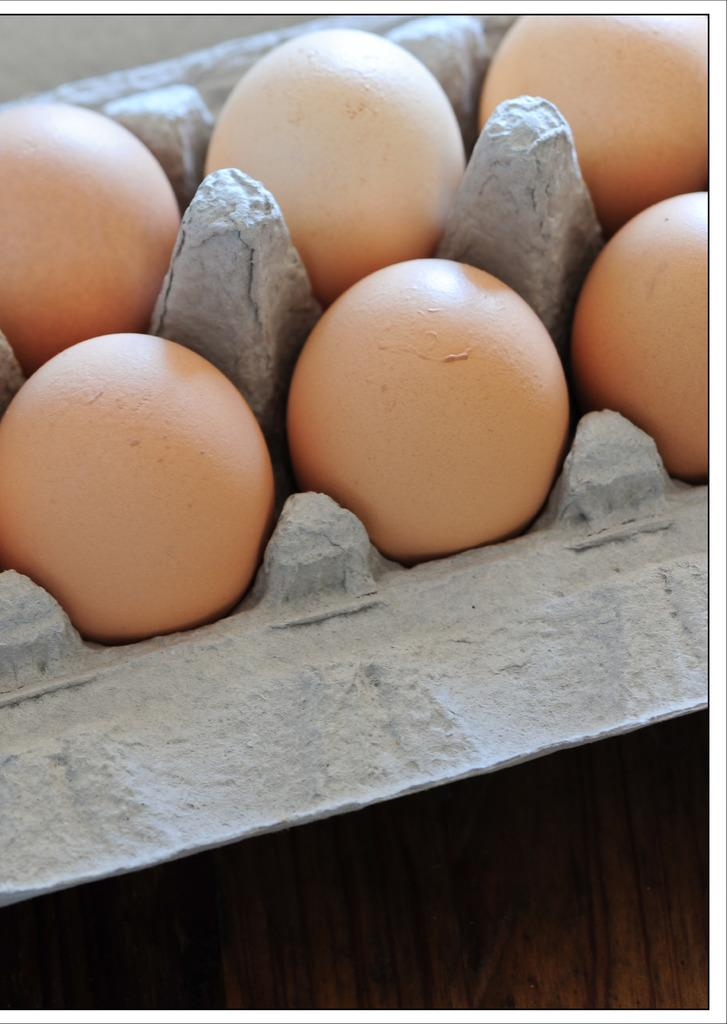What is present in the tray in the image? There are eggs in a tray in the image. How are the eggs arranged in the tray? The eggs are arranged in a specific pattern or order in the tray. What might be the purpose of the tray with eggs? The tray with eggs might be for cooking, baking, or decoration purposes. What type of powder can be seen on the eggs in the image? There is no powder visible on the eggs in the image. Is there a picture of a judge on the tray with the eggs? There is no picture of a judge or any other person present on the tray with the eggs. 